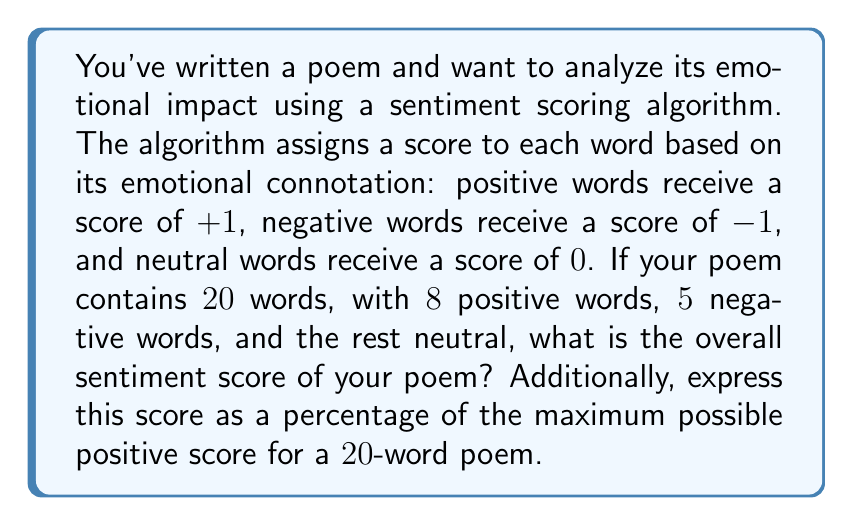Could you help me with this problem? Let's approach this step-by-step:

1. Calculate the sentiment score:
   - Positive words: 8 × (+1) = +8
   - Negative words: 5 × (-1) = -5
   - Neutral words: 7 × 0 = 0
   
   Overall sentiment score: $8 + (-5) + 0 = 3$

2. Calculate the maximum possible positive score for a 20-word poem:
   If all words were positive, the maximum score would be:
   $20 \times (+1) = 20$

3. Express the actual score as a percentage of the maximum score:
   $$\text{Percentage} = \frac{\text{Actual Score}}{\text{Maximum Score}} \times 100\%$$
   $$= \frac{3}{20} \times 100\%$$
   $$= 0.15 \times 100\%$$
   $$= 15\%$$

This means your poem has a slightly positive overall sentiment, with a score that is 15% of the maximum possible positive score.
Answer: The overall sentiment score is 3, which is 15% of the maximum possible positive score for a 20-word poem. 